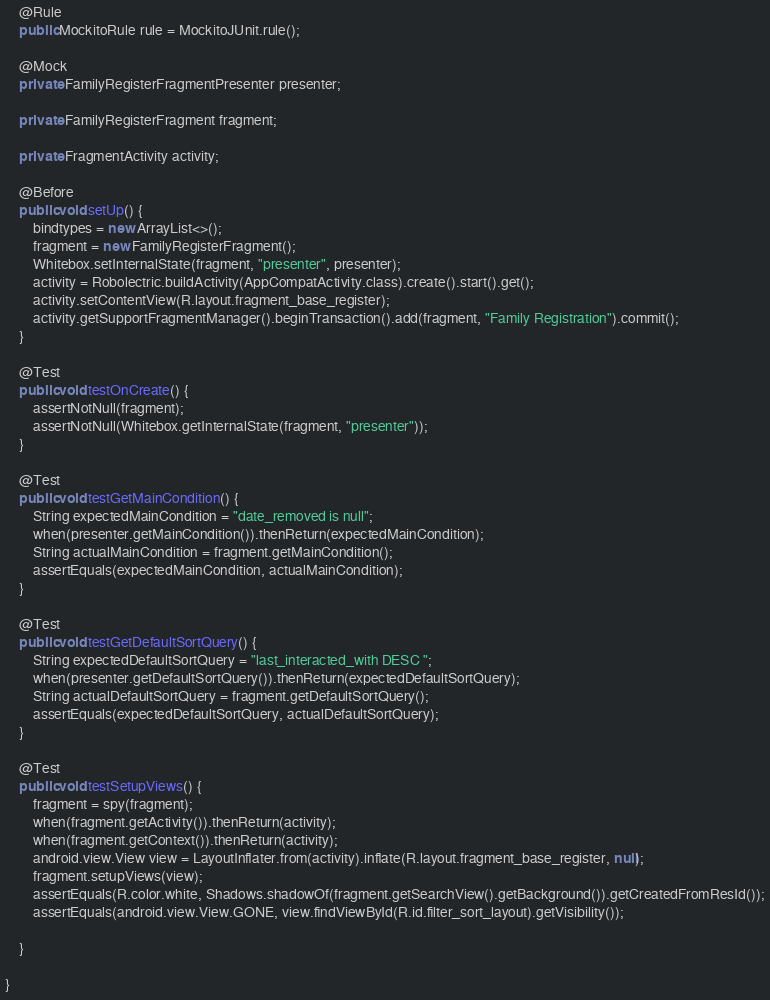Convert code to text. <code><loc_0><loc_0><loc_500><loc_500><_Java_>
    @Rule
    public MockitoRule rule = MockitoJUnit.rule();

    @Mock
    private FamilyRegisterFragmentPresenter presenter;

    private FamilyRegisterFragment fragment;

    private FragmentActivity activity;

    @Before
    public void setUp() {
        bindtypes = new ArrayList<>();
        fragment = new FamilyRegisterFragment();
        Whitebox.setInternalState(fragment, "presenter", presenter);
        activity = Robolectric.buildActivity(AppCompatActivity.class).create().start().get();
        activity.setContentView(R.layout.fragment_base_register);
        activity.getSupportFragmentManager().beginTransaction().add(fragment, "Family Registration").commit();
    }

    @Test
    public void testOnCreate() {
        assertNotNull(fragment);
        assertNotNull(Whitebox.getInternalState(fragment, "presenter"));
    }

    @Test
    public void testGetMainCondition() {
        String expectedMainCondition = "date_removed is null";
        when(presenter.getMainCondition()).thenReturn(expectedMainCondition);
        String actualMainCondition = fragment.getMainCondition();
        assertEquals(expectedMainCondition, actualMainCondition);
    }

    @Test
    public void testGetDefaultSortQuery() {
        String expectedDefaultSortQuery = "last_interacted_with DESC ";
        when(presenter.getDefaultSortQuery()).thenReturn(expectedDefaultSortQuery);
        String actualDefaultSortQuery = fragment.getDefaultSortQuery();
        assertEquals(expectedDefaultSortQuery, actualDefaultSortQuery);
    }

    @Test
    public void testSetupViews() {
        fragment = spy(fragment);
        when(fragment.getActivity()).thenReturn(activity);
        when(fragment.getContext()).thenReturn(activity);
        android.view.View view = LayoutInflater.from(activity).inflate(R.layout.fragment_base_register, null);
        fragment.setupViews(view);
        assertEquals(R.color.white, Shadows.shadowOf(fragment.getSearchView().getBackground()).getCreatedFromResId());
        assertEquals(android.view.View.GONE, view.findViewById(R.id.filter_sort_layout).getVisibility());

    }

}
</code> 